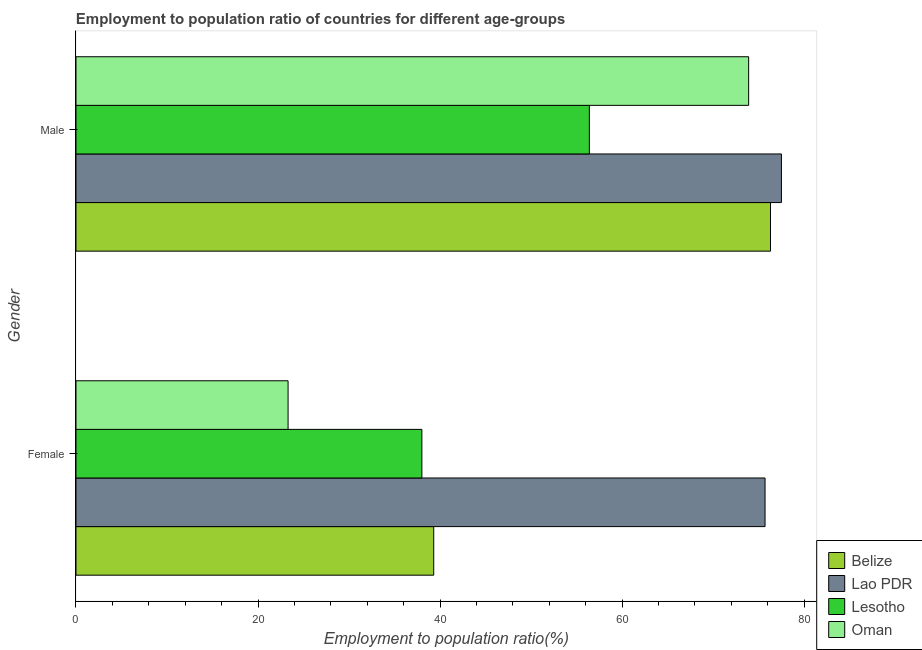What is the employment to population ratio(male) in Lesotho?
Keep it short and to the point. 56.4. Across all countries, what is the maximum employment to population ratio(male)?
Offer a very short reply. 77.5. Across all countries, what is the minimum employment to population ratio(male)?
Ensure brevity in your answer.  56.4. In which country was the employment to population ratio(male) maximum?
Your answer should be compact. Lao PDR. In which country was the employment to population ratio(female) minimum?
Make the answer very short. Oman. What is the total employment to population ratio(female) in the graph?
Your answer should be very brief. 176.3. What is the difference between the employment to population ratio(male) in Belize and that in Lesotho?
Your answer should be very brief. 19.9. What is the difference between the employment to population ratio(female) in Belize and the employment to population ratio(male) in Oman?
Keep it short and to the point. -34.6. What is the average employment to population ratio(female) per country?
Make the answer very short. 44.07. What is the difference between the employment to population ratio(female) and employment to population ratio(male) in Lao PDR?
Provide a short and direct response. -1.8. What is the ratio of the employment to population ratio(female) in Belize to that in Lesotho?
Keep it short and to the point. 1.03. What does the 3rd bar from the top in Female represents?
Provide a short and direct response. Lao PDR. What does the 3rd bar from the bottom in Female represents?
Give a very brief answer. Lesotho. What is the difference between two consecutive major ticks on the X-axis?
Ensure brevity in your answer.  20. Are the values on the major ticks of X-axis written in scientific E-notation?
Give a very brief answer. No. Does the graph contain grids?
Provide a short and direct response. No. Where does the legend appear in the graph?
Offer a very short reply. Bottom right. What is the title of the graph?
Ensure brevity in your answer.  Employment to population ratio of countries for different age-groups. What is the label or title of the Y-axis?
Offer a very short reply. Gender. What is the Employment to population ratio(%) of Belize in Female?
Offer a terse response. 39.3. What is the Employment to population ratio(%) in Lao PDR in Female?
Provide a short and direct response. 75.7. What is the Employment to population ratio(%) of Oman in Female?
Give a very brief answer. 23.3. What is the Employment to population ratio(%) of Belize in Male?
Provide a succinct answer. 76.3. What is the Employment to population ratio(%) in Lao PDR in Male?
Ensure brevity in your answer.  77.5. What is the Employment to population ratio(%) in Lesotho in Male?
Your answer should be very brief. 56.4. What is the Employment to population ratio(%) of Oman in Male?
Your answer should be compact. 73.9. Across all Gender, what is the maximum Employment to population ratio(%) of Belize?
Your answer should be very brief. 76.3. Across all Gender, what is the maximum Employment to population ratio(%) of Lao PDR?
Your answer should be compact. 77.5. Across all Gender, what is the maximum Employment to population ratio(%) in Lesotho?
Your response must be concise. 56.4. Across all Gender, what is the maximum Employment to population ratio(%) of Oman?
Provide a succinct answer. 73.9. Across all Gender, what is the minimum Employment to population ratio(%) of Belize?
Keep it short and to the point. 39.3. Across all Gender, what is the minimum Employment to population ratio(%) of Lao PDR?
Make the answer very short. 75.7. Across all Gender, what is the minimum Employment to population ratio(%) in Oman?
Provide a short and direct response. 23.3. What is the total Employment to population ratio(%) of Belize in the graph?
Make the answer very short. 115.6. What is the total Employment to population ratio(%) of Lao PDR in the graph?
Your response must be concise. 153.2. What is the total Employment to population ratio(%) of Lesotho in the graph?
Give a very brief answer. 94.4. What is the total Employment to population ratio(%) in Oman in the graph?
Give a very brief answer. 97.2. What is the difference between the Employment to population ratio(%) of Belize in Female and that in Male?
Give a very brief answer. -37. What is the difference between the Employment to population ratio(%) of Lao PDR in Female and that in Male?
Ensure brevity in your answer.  -1.8. What is the difference between the Employment to population ratio(%) in Lesotho in Female and that in Male?
Keep it short and to the point. -18.4. What is the difference between the Employment to population ratio(%) of Oman in Female and that in Male?
Offer a terse response. -50.6. What is the difference between the Employment to population ratio(%) of Belize in Female and the Employment to population ratio(%) of Lao PDR in Male?
Provide a short and direct response. -38.2. What is the difference between the Employment to population ratio(%) of Belize in Female and the Employment to population ratio(%) of Lesotho in Male?
Your answer should be compact. -17.1. What is the difference between the Employment to population ratio(%) in Belize in Female and the Employment to population ratio(%) in Oman in Male?
Give a very brief answer. -34.6. What is the difference between the Employment to population ratio(%) in Lao PDR in Female and the Employment to population ratio(%) in Lesotho in Male?
Offer a very short reply. 19.3. What is the difference between the Employment to population ratio(%) in Lao PDR in Female and the Employment to population ratio(%) in Oman in Male?
Provide a succinct answer. 1.8. What is the difference between the Employment to population ratio(%) of Lesotho in Female and the Employment to population ratio(%) of Oman in Male?
Your response must be concise. -35.9. What is the average Employment to population ratio(%) of Belize per Gender?
Provide a short and direct response. 57.8. What is the average Employment to population ratio(%) of Lao PDR per Gender?
Ensure brevity in your answer.  76.6. What is the average Employment to population ratio(%) of Lesotho per Gender?
Provide a short and direct response. 47.2. What is the average Employment to population ratio(%) in Oman per Gender?
Your answer should be very brief. 48.6. What is the difference between the Employment to population ratio(%) in Belize and Employment to population ratio(%) in Lao PDR in Female?
Offer a very short reply. -36.4. What is the difference between the Employment to population ratio(%) of Lao PDR and Employment to population ratio(%) of Lesotho in Female?
Provide a succinct answer. 37.7. What is the difference between the Employment to population ratio(%) of Lao PDR and Employment to population ratio(%) of Oman in Female?
Your answer should be very brief. 52.4. What is the difference between the Employment to population ratio(%) of Belize and Employment to population ratio(%) of Lao PDR in Male?
Your answer should be compact. -1.2. What is the difference between the Employment to population ratio(%) of Belize and Employment to population ratio(%) of Lesotho in Male?
Your response must be concise. 19.9. What is the difference between the Employment to population ratio(%) in Lao PDR and Employment to population ratio(%) in Lesotho in Male?
Provide a succinct answer. 21.1. What is the difference between the Employment to population ratio(%) in Lesotho and Employment to population ratio(%) in Oman in Male?
Your answer should be very brief. -17.5. What is the ratio of the Employment to population ratio(%) of Belize in Female to that in Male?
Provide a short and direct response. 0.52. What is the ratio of the Employment to population ratio(%) in Lao PDR in Female to that in Male?
Ensure brevity in your answer.  0.98. What is the ratio of the Employment to population ratio(%) in Lesotho in Female to that in Male?
Your answer should be compact. 0.67. What is the ratio of the Employment to population ratio(%) in Oman in Female to that in Male?
Your answer should be compact. 0.32. What is the difference between the highest and the second highest Employment to population ratio(%) in Belize?
Provide a short and direct response. 37. What is the difference between the highest and the second highest Employment to population ratio(%) in Lao PDR?
Offer a terse response. 1.8. What is the difference between the highest and the second highest Employment to population ratio(%) of Oman?
Make the answer very short. 50.6. What is the difference between the highest and the lowest Employment to population ratio(%) in Lao PDR?
Provide a short and direct response. 1.8. What is the difference between the highest and the lowest Employment to population ratio(%) of Lesotho?
Make the answer very short. 18.4. What is the difference between the highest and the lowest Employment to population ratio(%) of Oman?
Offer a very short reply. 50.6. 